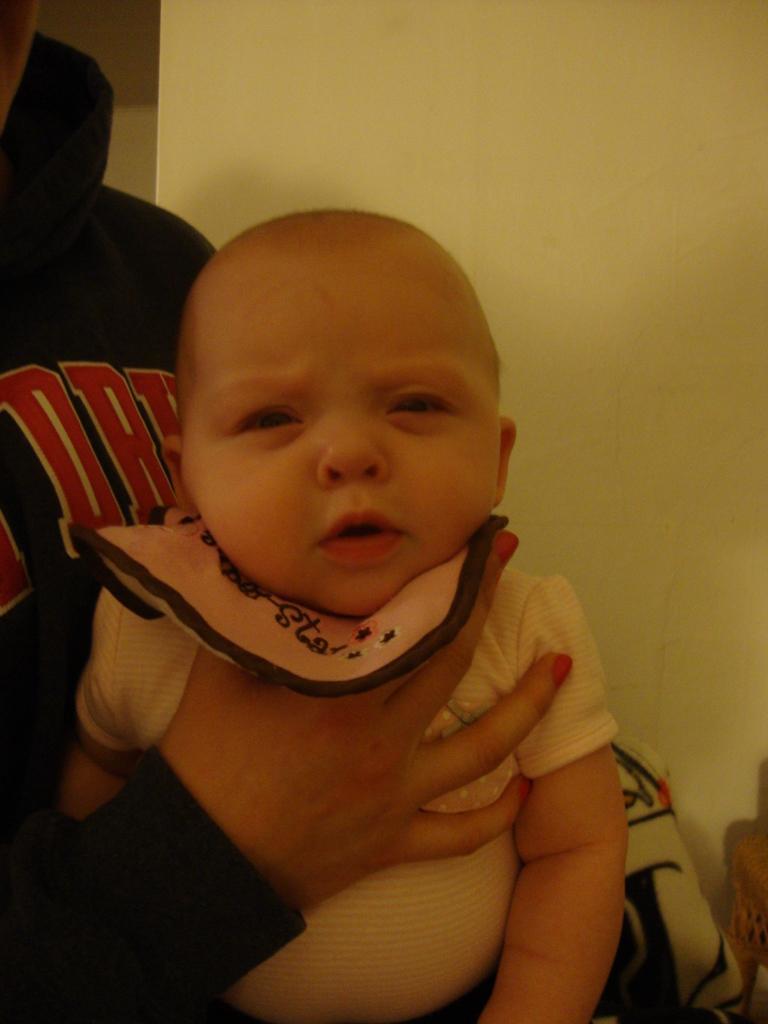Can you describe this image briefly? There is a person holding a baby on the neck. In the back there is a wall. 